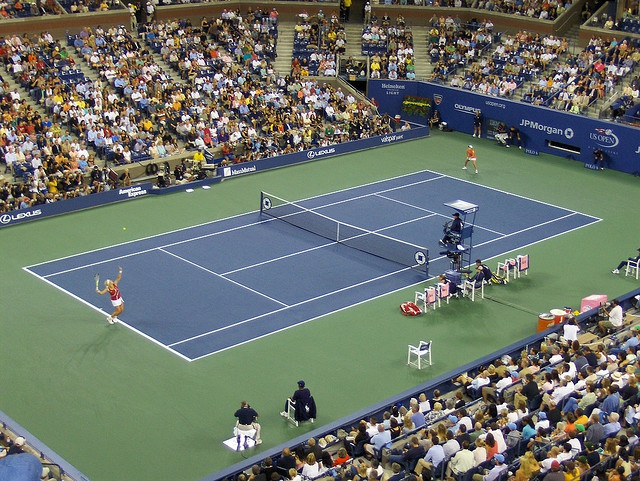Describe the objects in this image and their specific colors. I can see people in gray, black, tan, and olive tones, chair in gray, navy, lightgray, and darkblue tones, people in gray, black, darkgray, and beige tones, people in gray, beige, darkgray, and black tones, and people in gray, lightgray, black, and olive tones in this image. 